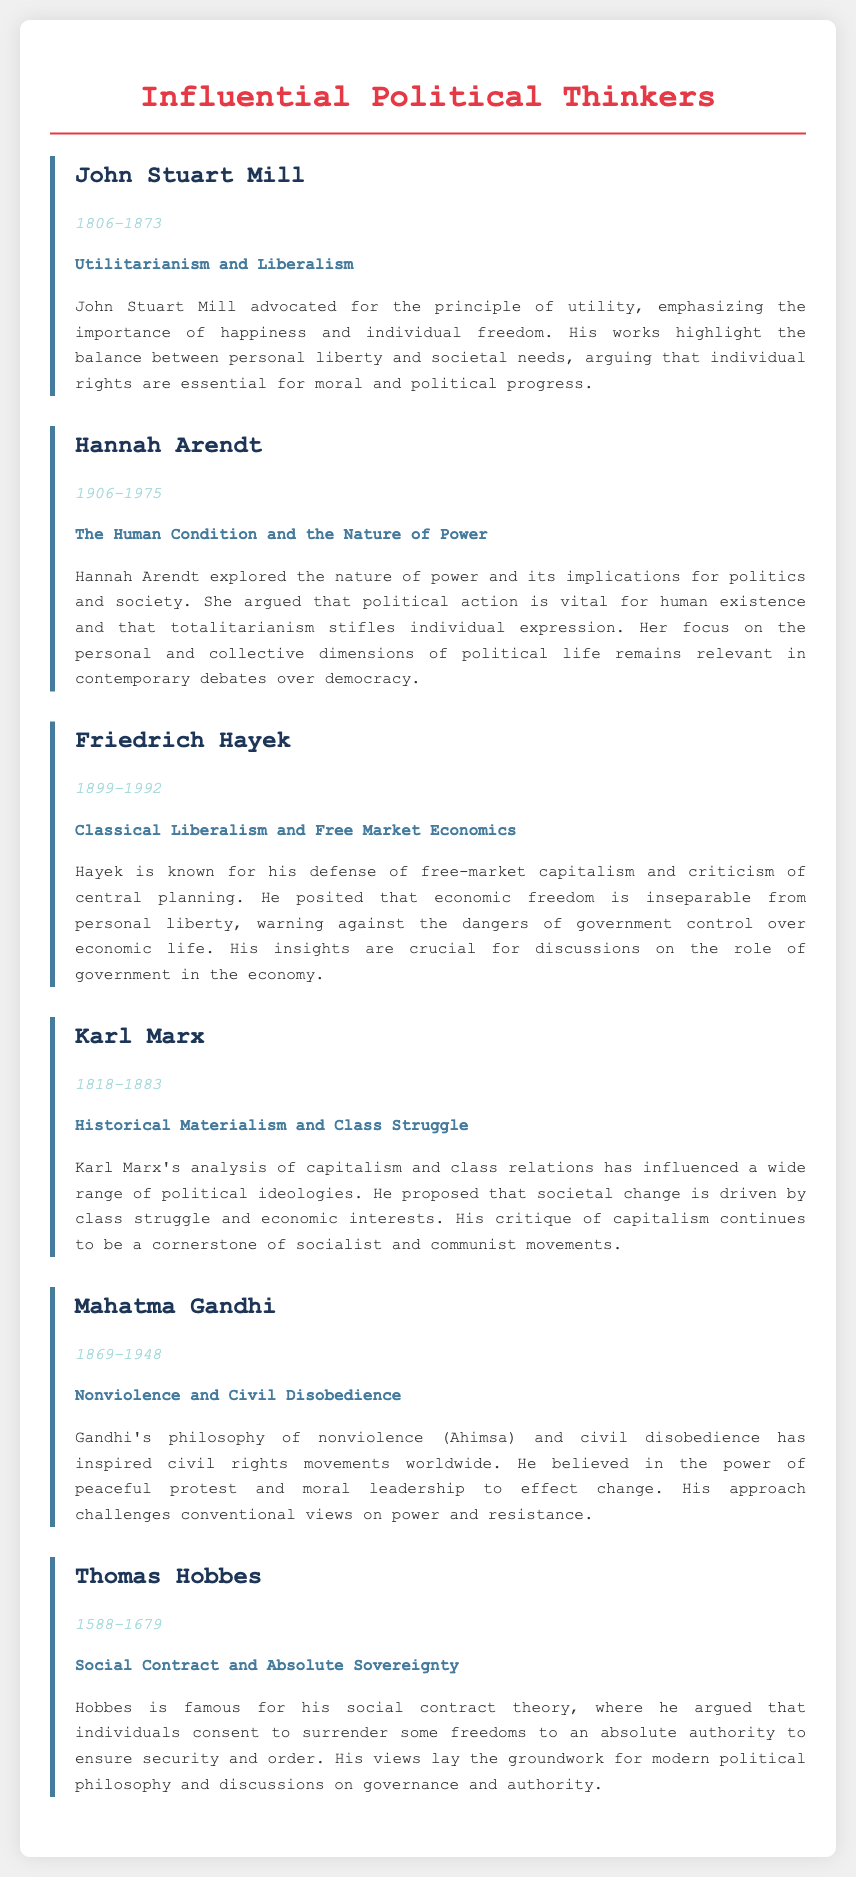What philosophical approach did John Stuart Mill advocate? John Stuart Mill's philosophy emphasizes the principle of utility, which focuses on happiness and individual freedom.
Answer: Utilitarianism and Liberalism In what year was Hannah Arendt born? According to the document, Hannah Arendt was born in 1906.
Answer: 1906 What is the main focus of Friedrich Hayek's philosophy? Friedrich Hayek's philosophy revolves around the defense of free-market capitalism and criticism of central planning.
Answer: Classical Liberalism and Free Market Economics Which thinker proposed the concept of Historical Materialism? The document states that Karl Marx proposed the concept of Historical Materialism.
Answer: Karl Marx What is the time period during which Mahatma Gandhi lived? Mahatma Gandhi lived from 1869 to 1948 according to the document.
Answer: 1869-1948 What does Thomas Hobbes's social contract theory emphasize? Thomas Hobbes's social contract theory emphasizes that individuals surrender some freedoms to an absolute authority for security and order.
Answer: Absolute Sovereignty How does Hannah Arendt's analysis relate to contemporary debates? Arendt's focus on political action and totalitarianism relates to current discussions on democracy and individual expression.
Answer: Political action and totalitarianism Which political thinker is associated with the idea of nonviolence? The document attributes the idea of nonviolence to Mahatma Gandhi.
Answer: Mahatma Gandhi What does the analysis of Marx's philosophy suggest about societal change? The analysis of Marx's philosophy suggests that societal change is driven by class struggle and economic interests.
Answer: Class struggle and economic interests 